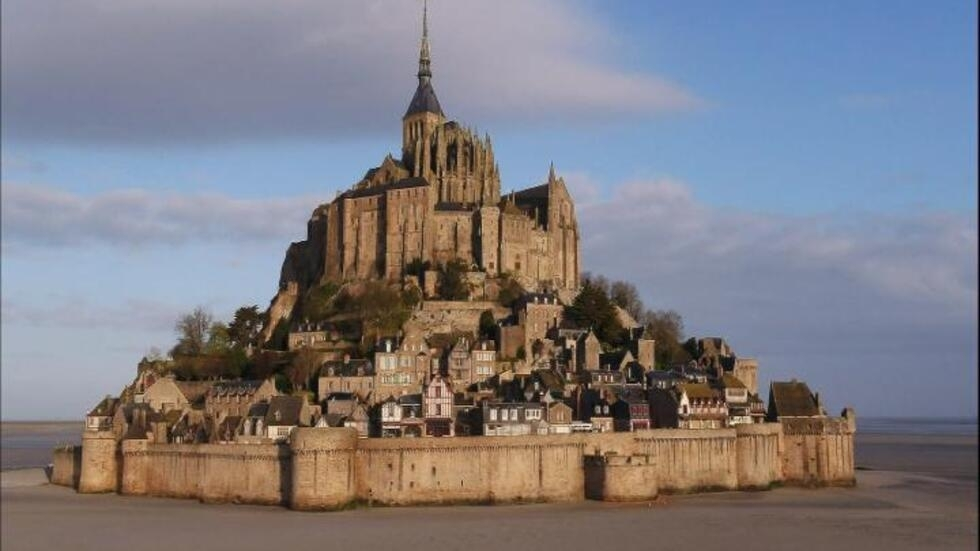What is this photo about? This photo captures the stunning Mont St Michel, an iconic French landmark known both for its architectural majesty and rich historical significance. Nestled on a rocky island, the grand medieval abbey towers above at the center, surrounded by ancient fortifications and a quaint village that once housed its monks. This structure is a marvel of medieval architecture, standing resilient through centuries. The image, with its expansive view of the island against a backdrop of vast skies and tidal plains, not only showcases the architectural and natural beauty but also hints at the strategic and religious importance of this UNESCO World Heritage site. The serene and almost ethereal quality of this picture invites the viewer to appreciate the tranquility and historical aura that Mont St Michel continues to emanate. 